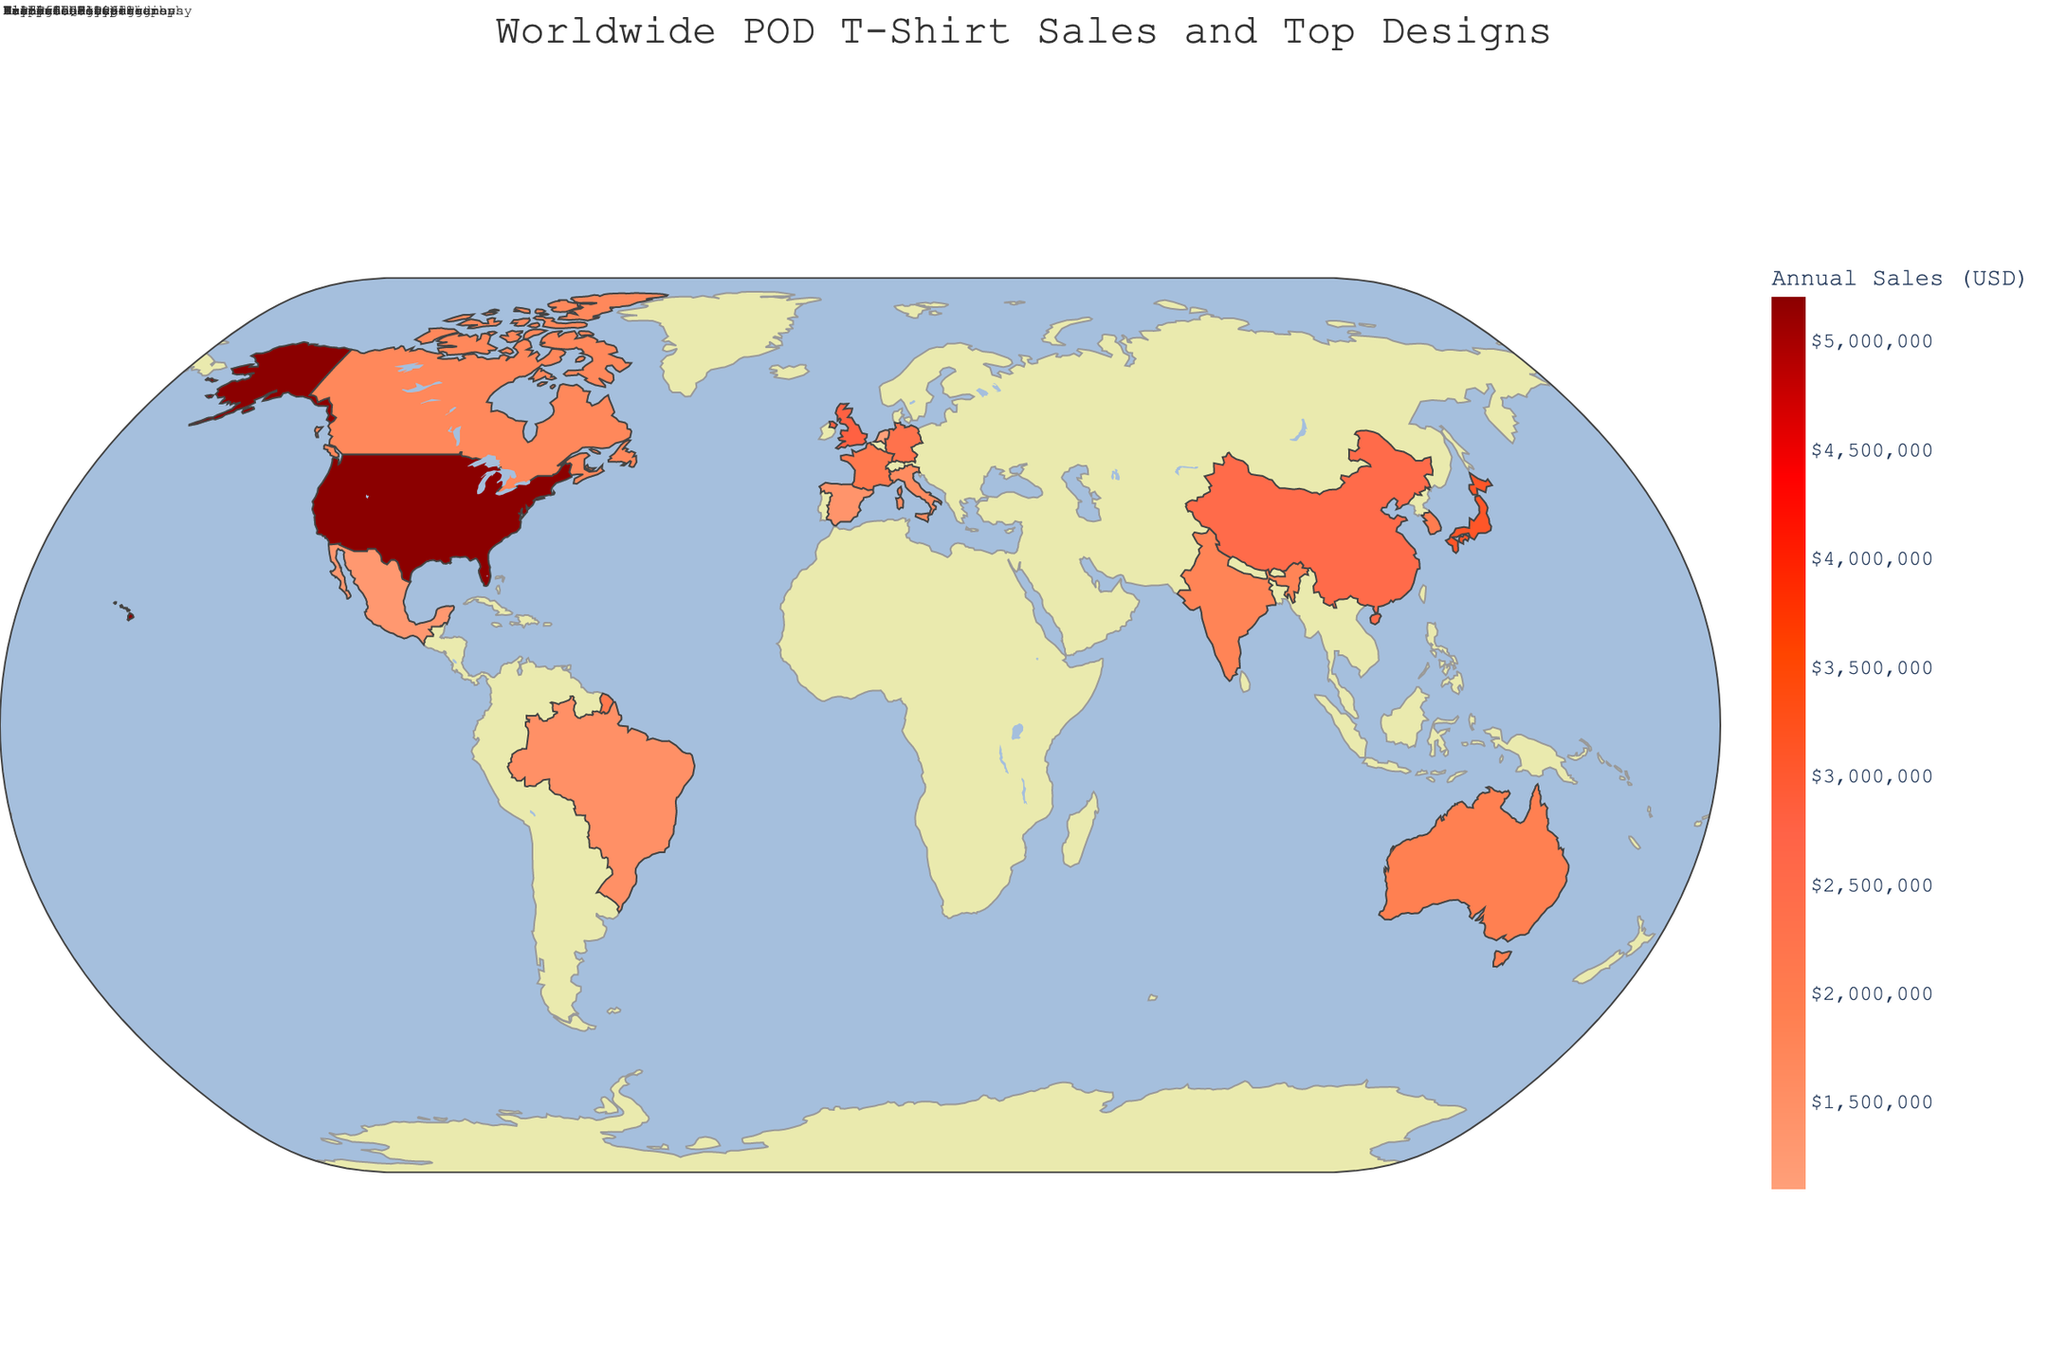What is the title of the figure? The title is usually found at the top of the figure and often indicates the main subject of the visualization. It helps to orient viewers about what they are looking at.
Answer: Worldwide POD T-Shirt Sales and Top Designs What is the top design for t-shirts in Europe? Look for the regions marked as Europe on the map and check the annotations for each country in that region. The top designs will be listed next to each country.
Answer: Vintage Logos, Eco-Friendly Slogans, Fashion Quotes, Art Deco Designs, Flamenco Motifs, Dutch Landscapes Which region shows the highest annual sales for POD t-shirts? Check the color intensity in the geographic plot, where darker shades usually indicate higher sales. Identify the region associated with the darkest color. If necessary, refer to the hover data on the map.
Answer: North America How do the annual sales of t-shirts in Germany compare to those in Japan? Locate Germany and Japan on the map and compare their colors based on the color intensity. You can also look at the hover data for exact sales figures.
Answer: Germany: $2,300,000, Japan: $3,100,000 How much more are the annual sales for the United States compared to Brazil? Find the annual sales figures for both the United States and Brazil from the map. Subtract Brazil's sales from those of the United States to get the difference.
Answer: $5,200,000 - $1,500,000 = $3,700,000 What are the top designs for t-shirts in Asia? Identify the countries in Asia on the map and look for the annotated top designs next to each country name.
Answer: Anime Characters, Bollywood Inspired, K-Pop Idols, Traditional Calligraphy Which country in North America has the lowest annual sales for POD t-shirts? Identify the countries in North America on the map and compare their respective sales figures, either by color intensity or hover data.
Answer: Mexico What is the average annual sales of POD t-shirts in Europe? Identify all European countries on the map and find their annual sales figures. Add these figures together and divide by the number of European countries.
Answer: ($2,800,000 + $2,300,000 + $2,100,000 + $1,600,000 + $1,400,000 + $1,100,000) / 6 = $1,883,333 (approx.) How do the sales figures for t-shirts in France and Italy compare? Look at the respective colors for France and Italy or use the hover data to get their sales figures. Compare these figures to determine which is higher and by how much.
Answer: France: $2,100,000, Italy: $1,600,000 What is the unique selling point of t-shirts in Brazil? Check the annotation next to Brazil on the map to find the top design that is likely the unique selling point for the country.
Answer: Tropical Patterns 